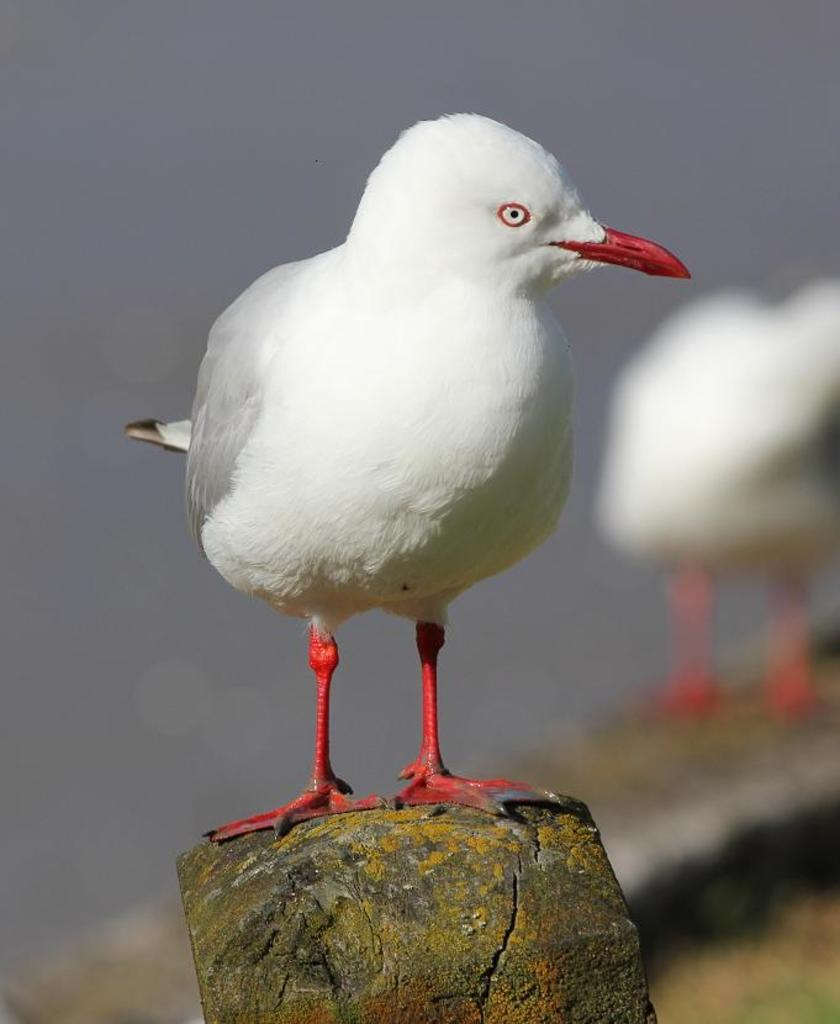What is the main subject of the image? There is a bird standing on a rock in the image. Can you describe the bird's appearance? The bird has white feathers and a red beak. Are there any other birds visible in the image? Yes, there is another bird in the background of the image. How would you describe the background of the image? The background of the image is blurred. What type of pot can be seen in the image? There is no pot present in the image. How many trees are visible in the image? There are no trees visible in the image. 